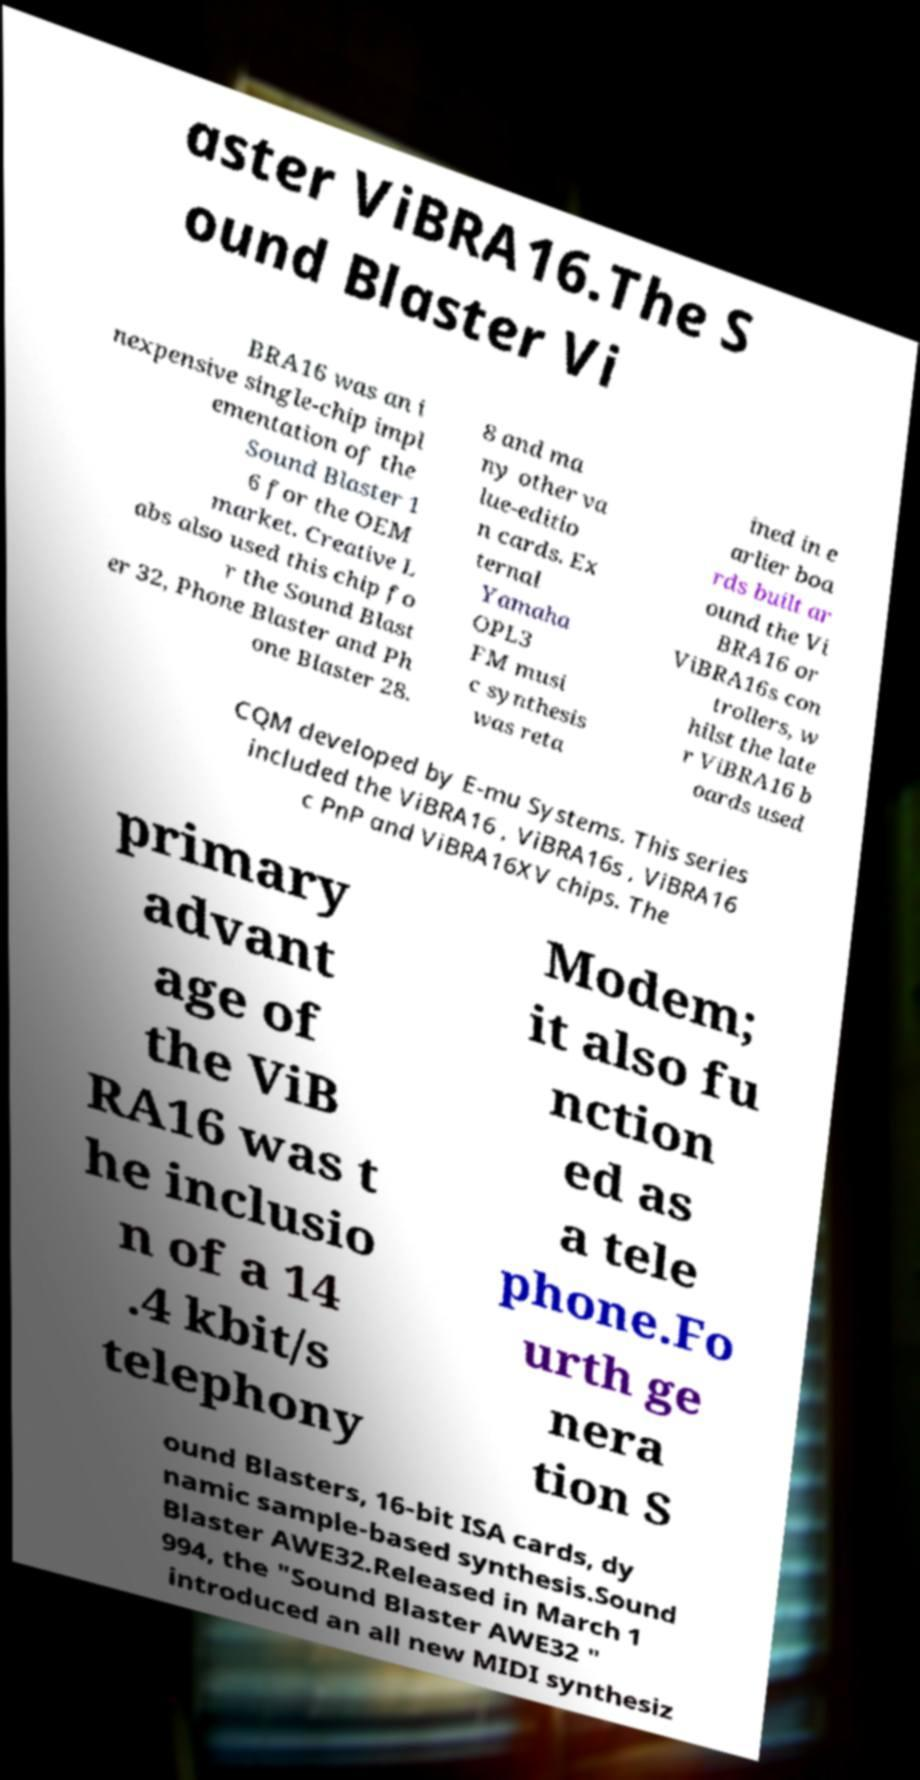Please identify and transcribe the text found in this image. aster ViBRA16.The S ound Blaster Vi BRA16 was an i nexpensive single-chip impl ementation of the Sound Blaster 1 6 for the OEM market. Creative L abs also used this chip fo r the Sound Blast er 32, Phone Blaster and Ph one Blaster 28. 8 and ma ny other va lue-editio n cards. Ex ternal Yamaha OPL3 FM musi c synthesis was reta ined in e arlier boa rds built ar ound the Vi BRA16 or ViBRA16s con trollers, w hilst the late r ViBRA16 b oards used CQM developed by E-mu Systems. This series included the ViBRA16 , ViBRA16s , ViBRA16 c PnP and ViBRA16XV chips. The primary advant age of the ViB RA16 was t he inclusio n of a 14 .4 kbit/s telephony Modem; it also fu nction ed as a tele phone.Fo urth ge nera tion S ound Blasters, 16-bit ISA cards, dy namic sample-based synthesis.Sound Blaster AWE32.Released in March 1 994, the "Sound Blaster AWE32 " introduced an all new MIDI synthesiz 